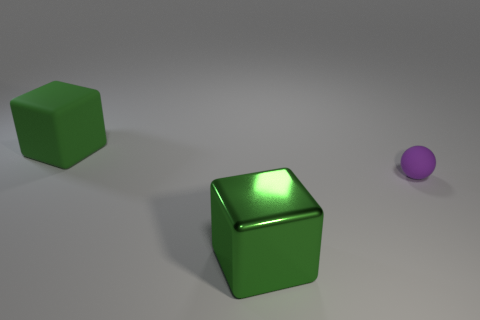How many matte things are tiny spheres or green cubes?
Provide a succinct answer. 2. What is the shape of the purple matte thing?
Your answer should be compact. Sphere. There is another green cube that is the same size as the shiny cube; what is its material?
Your answer should be very brief. Rubber. What number of tiny things are rubber objects or balls?
Your answer should be very brief. 1. Are there any balls?
Offer a very short reply. Yes. There is a thing that is the same material as the tiny purple ball; what size is it?
Your answer should be compact. Large. What number of other things are the same material as the small purple sphere?
Offer a terse response. 1. What number of large blocks are behind the purple rubber thing and in front of the tiny purple ball?
Provide a short and direct response. 0. The small rubber thing has what color?
Provide a succinct answer. Purple. What is the material of the other big green thing that is the same shape as the big green rubber thing?
Keep it short and to the point. Metal. 